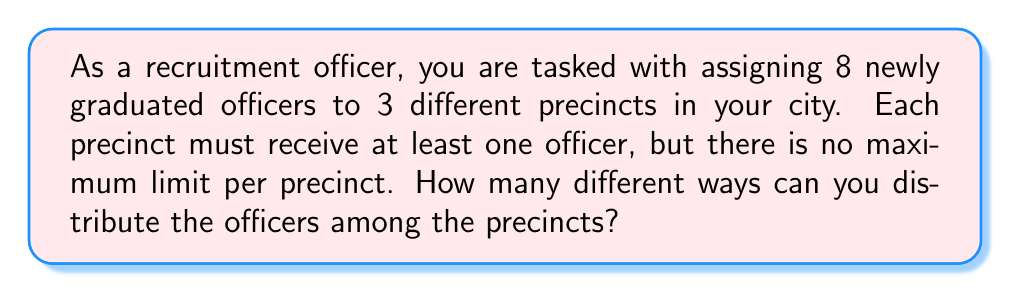Show me your answer to this math problem. This problem can be solved using the concept of combinations with repetition, also known as stars and bars.

1) We have 8 officers to distribute (the stars) and 2 dividers (the bars) to separate the 3 precincts.

2) The total number of positions we need to consider is:
   8 officers + 2 dividers = 10 positions

3) We need to choose 2 positions out of these 10 for the dividers. Once the dividers are placed, the distribution of officers is determined.

4) This is equivalent to choosing 2 items from 10, where order doesn't matter. This is represented by the combination formula:

   $$\binom{10}{2} = \frac{10!}{2!(10-2)!} = \frac{10!}{2!8!}$$

5) Calculating this:
   $$\frac{10 * 9}{2 * 1} = \frac{90}{2} = 45$$

Therefore, there are 45 different ways to distribute the officers.

Note: This method ensures that each precinct gets at least one officer because we are using 2 dividers to create 3 non-empty groups.
Answer: 45 ways 